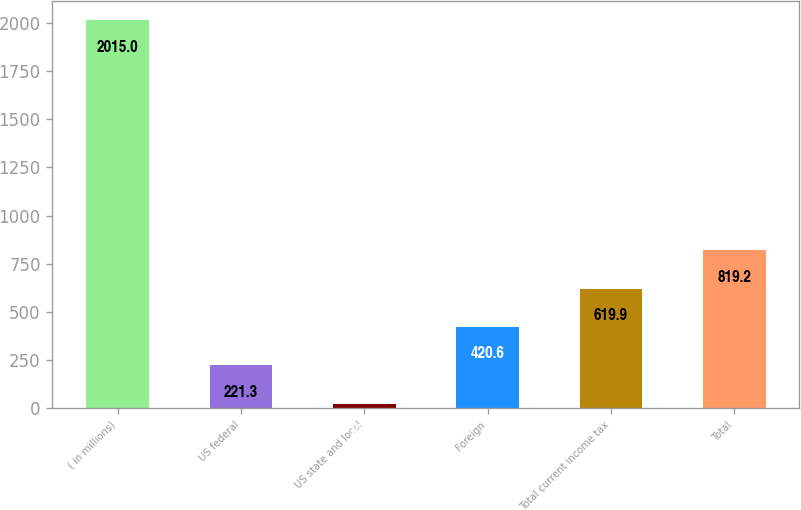Convert chart. <chart><loc_0><loc_0><loc_500><loc_500><bar_chart><fcel>( in millions)<fcel>US federal<fcel>US state and local<fcel>Foreign<fcel>Total current income tax<fcel>Total<nl><fcel>2015<fcel>221.3<fcel>22<fcel>420.6<fcel>619.9<fcel>819.2<nl></chart> 